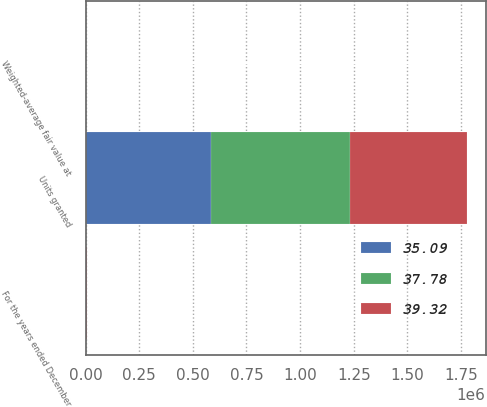Convert chart to OTSL. <chart><loc_0><loc_0><loc_500><loc_500><stacked_bar_chart><ecel><fcel>For the years ended December<fcel>Units granted<fcel>Weighted-average fair value at<nl><fcel>37.78<fcel>2010<fcel>650407<fcel>39.32<nl><fcel>35.09<fcel>2009<fcel>583864<fcel>35.09<nl><fcel>39.32<fcel>2008<fcel>541623<fcel>37.78<nl></chart> 